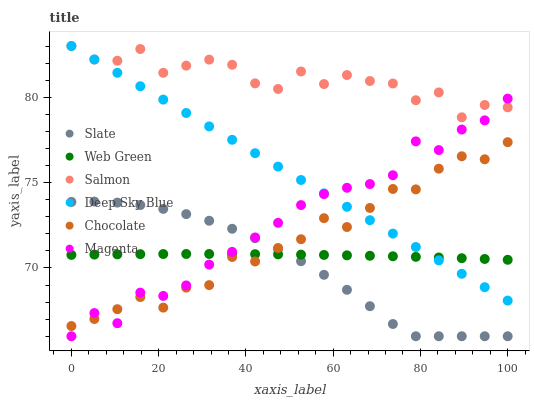Does Slate have the minimum area under the curve?
Answer yes or no. Yes. Does Salmon have the maximum area under the curve?
Answer yes or no. Yes. Does Web Green have the minimum area under the curve?
Answer yes or no. No. Does Web Green have the maximum area under the curve?
Answer yes or no. No. Is Deep Sky Blue the smoothest?
Answer yes or no. Yes. Is Salmon the roughest?
Answer yes or no. Yes. Is Web Green the smoothest?
Answer yes or no. No. Is Web Green the roughest?
Answer yes or no. No. Does Slate have the lowest value?
Answer yes or no. Yes. Does Web Green have the lowest value?
Answer yes or no. No. Does Deep Sky Blue have the highest value?
Answer yes or no. Yes. Does Web Green have the highest value?
Answer yes or no. No. Is Slate less than Salmon?
Answer yes or no. Yes. Is Salmon greater than Chocolate?
Answer yes or no. Yes. Does Salmon intersect Deep Sky Blue?
Answer yes or no. Yes. Is Salmon less than Deep Sky Blue?
Answer yes or no. No. Is Salmon greater than Deep Sky Blue?
Answer yes or no. No. Does Slate intersect Salmon?
Answer yes or no. No. 